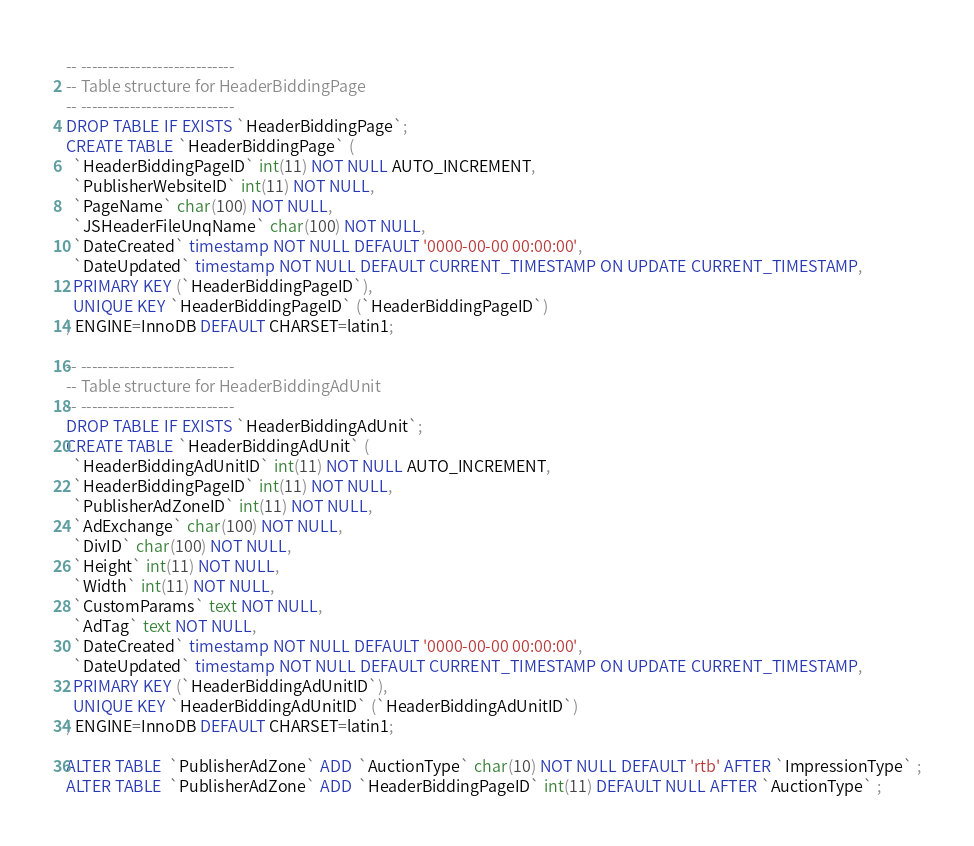Convert code to text. <code><loc_0><loc_0><loc_500><loc_500><_SQL_>-- ----------------------------
-- Table structure for HeaderBiddingPage
-- ----------------------------
DROP TABLE IF EXISTS `HeaderBiddingPage`;
CREATE TABLE `HeaderBiddingPage` (
  `HeaderBiddingPageID` int(11) NOT NULL AUTO_INCREMENT,
  `PublisherWebsiteID` int(11) NOT NULL,
  `PageName` char(100) NOT NULL,
  `JSHeaderFileUnqName` char(100) NOT NULL,
  `DateCreated` timestamp NOT NULL DEFAULT '0000-00-00 00:00:00',
  `DateUpdated` timestamp NOT NULL DEFAULT CURRENT_TIMESTAMP ON UPDATE CURRENT_TIMESTAMP,
  PRIMARY KEY (`HeaderBiddingPageID`),
  UNIQUE KEY `HeaderBiddingPageID` (`HeaderBiddingPageID`)
) ENGINE=InnoDB DEFAULT CHARSET=latin1;

-- ----------------------------
-- Table structure for HeaderBiddingAdUnit
-- ----------------------------
DROP TABLE IF EXISTS `HeaderBiddingAdUnit`;
CREATE TABLE `HeaderBiddingAdUnit` (
  `HeaderBiddingAdUnitID` int(11) NOT NULL AUTO_INCREMENT,
  `HeaderBiddingPageID` int(11) NOT NULL,
  `PublisherAdZoneID` int(11) NOT NULL,
  `AdExchange` char(100) NOT NULL,
  `DivID` char(100) NOT NULL,
  `Height` int(11) NOT NULL,
  `Width` int(11) NOT NULL,
  `CustomParams` text NOT NULL,
  `AdTag` text NOT NULL,
  `DateCreated` timestamp NOT NULL DEFAULT '0000-00-00 00:00:00',
  `DateUpdated` timestamp NOT NULL DEFAULT CURRENT_TIMESTAMP ON UPDATE CURRENT_TIMESTAMP,
  PRIMARY KEY (`HeaderBiddingAdUnitID`),
  UNIQUE KEY `HeaderBiddingAdUnitID` (`HeaderBiddingAdUnitID`)
) ENGINE=InnoDB DEFAULT CHARSET=latin1;

ALTER TABLE  `PublisherAdZone` ADD  `AuctionType` char(10) NOT NULL DEFAULT 'rtb' AFTER `ImpressionType` ;
ALTER TABLE  `PublisherAdZone` ADD  `HeaderBiddingPageID` int(11) DEFAULT NULL AFTER `AuctionType` ;
</code> 